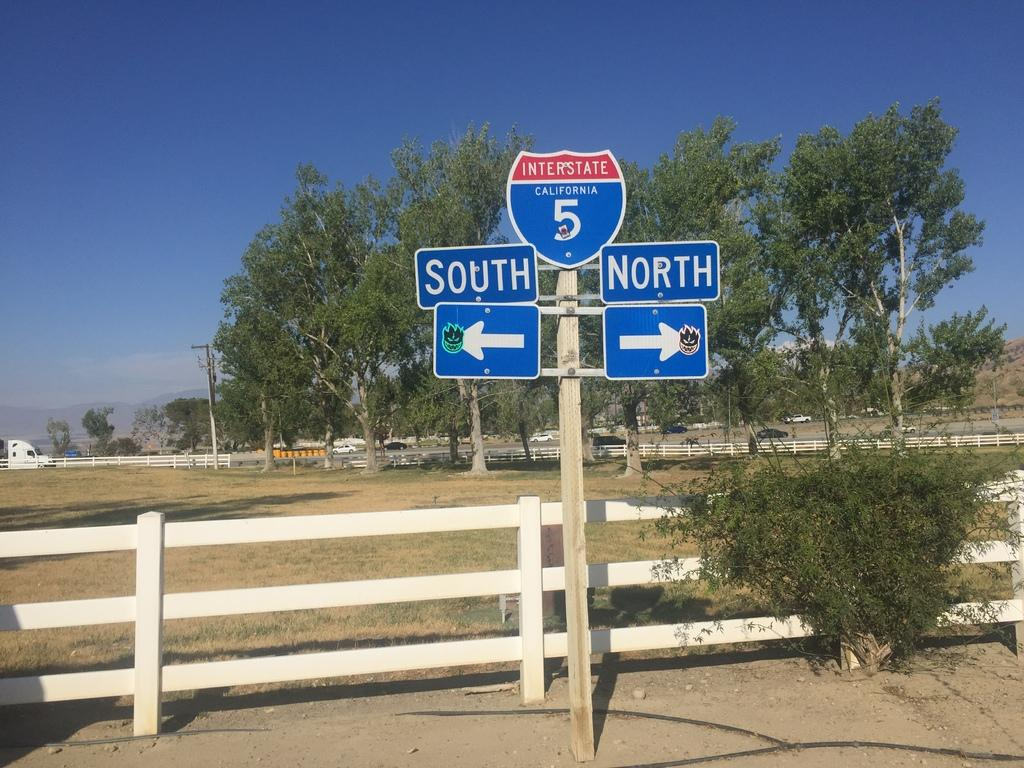<image>
Present a compact description of the photo's key features. Directional road sign for Interstate 5 in California. 